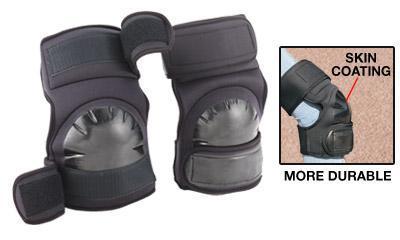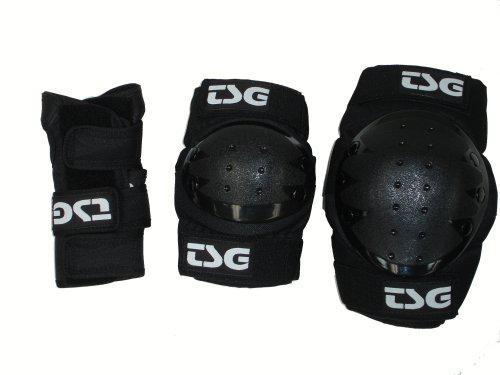The first image is the image on the left, the second image is the image on the right. Analyze the images presented: Is the assertion "The image on the right has 3 objects arranged from smallest to largest." valid? Answer yes or no. Yes. The first image is the image on the left, the second image is the image on the right. For the images shown, is this caption "In both images, there are three different types of knee pads in a row." true? Answer yes or no. No. 